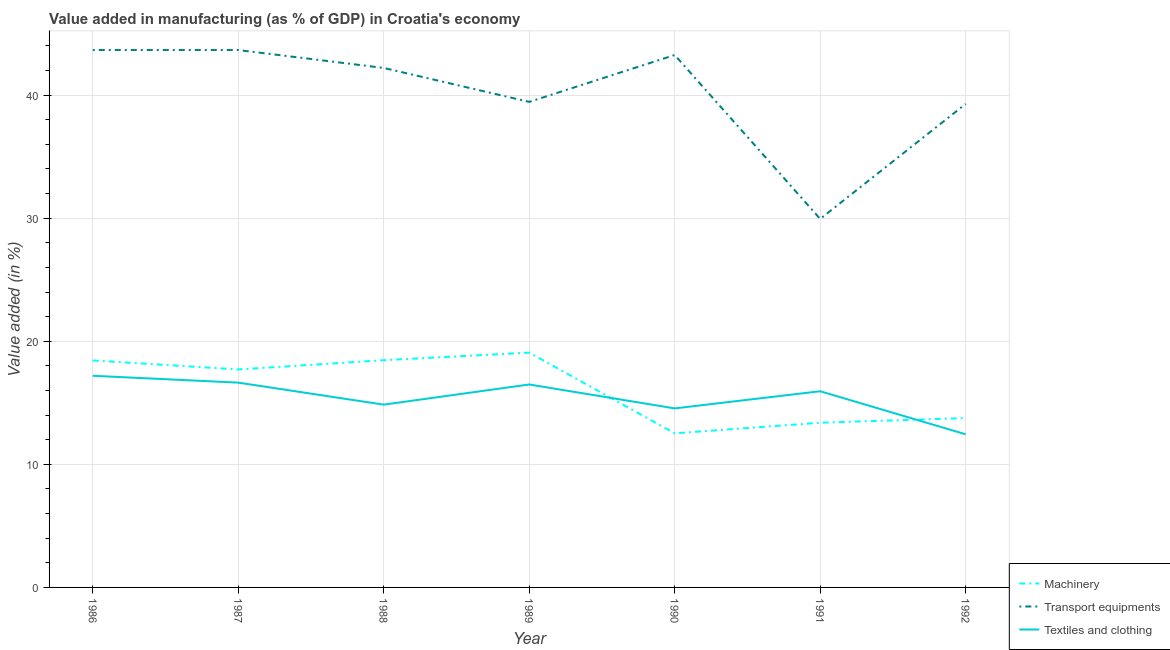Is the number of lines equal to the number of legend labels?
Provide a short and direct response. Yes. What is the value added in manufacturing machinery in 1988?
Offer a very short reply. 18.46. Across all years, what is the maximum value added in manufacturing textile and clothing?
Your response must be concise. 17.19. Across all years, what is the minimum value added in manufacturing machinery?
Provide a succinct answer. 12.52. In which year was the value added in manufacturing transport equipments maximum?
Provide a succinct answer. 1986. What is the total value added in manufacturing machinery in the graph?
Provide a short and direct response. 113.34. What is the difference between the value added in manufacturing textile and clothing in 1986 and that in 1991?
Provide a short and direct response. 1.26. What is the difference between the value added in manufacturing textile and clothing in 1992 and the value added in manufacturing transport equipments in 1988?
Your response must be concise. -29.76. What is the average value added in manufacturing textile and clothing per year?
Your response must be concise. 15.44. In the year 1989, what is the difference between the value added in manufacturing machinery and value added in manufacturing textile and clothing?
Keep it short and to the point. 2.59. What is the ratio of the value added in manufacturing transport equipments in 1989 to that in 1991?
Give a very brief answer. 1.32. Is the value added in manufacturing transport equipments in 1988 less than that in 1992?
Ensure brevity in your answer.  No. What is the difference between the highest and the second highest value added in manufacturing transport equipments?
Provide a succinct answer. 0. What is the difference between the highest and the lowest value added in manufacturing transport equipments?
Give a very brief answer. 13.72. Is it the case that in every year, the sum of the value added in manufacturing machinery and value added in manufacturing transport equipments is greater than the value added in manufacturing textile and clothing?
Offer a very short reply. Yes. Is the value added in manufacturing transport equipments strictly greater than the value added in manufacturing textile and clothing over the years?
Your response must be concise. Yes. How many years are there in the graph?
Give a very brief answer. 7. Are the values on the major ticks of Y-axis written in scientific E-notation?
Your response must be concise. No. Does the graph contain any zero values?
Offer a terse response. No. Does the graph contain grids?
Offer a terse response. Yes. Where does the legend appear in the graph?
Ensure brevity in your answer.  Bottom right. How many legend labels are there?
Ensure brevity in your answer.  3. How are the legend labels stacked?
Ensure brevity in your answer.  Vertical. What is the title of the graph?
Offer a terse response. Value added in manufacturing (as % of GDP) in Croatia's economy. What is the label or title of the X-axis?
Ensure brevity in your answer.  Year. What is the label or title of the Y-axis?
Make the answer very short. Value added (in %). What is the Value added (in %) of Machinery in 1986?
Keep it short and to the point. 18.44. What is the Value added (in %) of Transport equipments in 1986?
Give a very brief answer. 43.66. What is the Value added (in %) in Textiles and clothing in 1986?
Keep it short and to the point. 17.19. What is the Value added (in %) in Machinery in 1987?
Offer a terse response. 17.71. What is the Value added (in %) in Transport equipments in 1987?
Keep it short and to the point. 43.66. What is the Value added (in %) in Textiles and clothing in 1987?
Make the answer very short. 16.64. What is the Value added (in %) in Machinery in 1988?
Your answer should be very brief. 18.46. What is the Value added (in %) of Transport equipments in 1988?
Offer a very short reply. 42.2. What is the Value added (in %) of Textiles and clothing in 1988?
Offer a terse response. 14.85. What is the Value added (in %) in Machinery in 1989?
Provide a succinct answer. 19.08. What is the Value added (in %) in Transport equipments in 1989?
Give a very brief answer. 39.44. What is the Value added (in %) of Textiles and clothing in 1989?
Make the answer very short. 16.49. What is the Value added (in %) in Machinery in 1990?
Your answer should be compact. 12.52. What is the Value added (in %) of Transport equipments in 1990?
Offer a very short reply. 43.25. What is the Value added (in %) in Textiles and clothing in 1990?
Your answer should be compact. 14.54. What is the Value added (in %) of Machinery in 1991?
Provide a succinct answer. 13.38. What is the Value added (in %) of Transport equipments in 1991?
Keep it short and to the point. 29.94. What is the Value added (in %) of Textiles and clothing in 1991?
Provide a short and direct response. 15.94. What is the Value added (in %) in Machinery in 1992?
Your answer should be very brief. 13.76. What is the Value added (in %) in Transport equipments in 1992?
Keep it short and to the point. 39.28. What is the Value added (in %) of Textiles and clothing in 1992?
Offer a terse response. 12.44. Across all years, what is the maximum Value added (in %) of Machinery?
Ensure brevity in your answer.  19.08. Across all years, what is the maximum Value added (in %) in Transport equipments?
Provide a succinct answer. 43.66. Across all years, what is the maximum Value added (in %) of Textiles and clothing?
Provide a short and direct response. 17.19. Across all years, what is the minimum Value added (in %) in Machinery?
Keep it short and to the point. 12.52. Across all years, what is the minimum Value added (in %) of Transport equipments?
Your answer should be compact. 29.94. Across all years, what is the minimum Value added (in %) of Textiles and clothing?
Your answer should be compact. 12.44. What is the total Value added (in %) of Machinery in the graph?
Provide a succinct answer. 113.34. What is the total Value added (in %) in Transport equipments in the graph?
Make the answer very short. 281.43. What is the total Value added (in %) of Textiles and clothing in the graph?
Make the answer very short. 108.09. What is the difference between the Value added (in %) of Machinery in 1986 and that in 1987?
Your answer should be compact. 0.73. What is the difference between the Value added (in %) in Transport equipments in 1986 and that in 1987?
Your answer should be compact. 0. What is the difference between the Value added (in %) in Textiles and clothing in 1986 and that in 1987?
Your answer should be compact. 0.56. What is the difference between the Value added (in %) in Machinery in 1986 and that in 1988?
Your answer should be very brief. -0.02. What is the difference between the Value added (in %) of Transport equipments in 1986 and that in 1988?
Give a very brief answer. 1.45. What is the difference between the Value added (in %) of Textiles and clothing in 1986 and that in 1988?
Keep it short and to the point. 2.34. What is the difference between the Value added (in %) of Machinery in 1986 and that in 1989?
Give a very brief answer. -0.63. What is the difference between the Value added (in %) of Transport equipments in 1986 and that in 1989?
Offer a terse response. 4.21. What is the difference between the Value added (in %) of Textiles and clothing in 1986 and that in 1989?
Give a very brief answer. 0.71. What is the difference between the Value added (in %) of Machinery in 1986 and that in 1990?
Give a very brief answer. 5.92. What is the difference between the Value added (in %) of Transport equipments in 1986 and that in 1990?
Give a very brief answer. 0.4. What is the difference between the Value added (in %) in Textiles and clothing in 1986 and that in 1990?
Your answer should be very brief. 2.65. What is the difference between the Value added (in %) of Machinery in 1986 and that in 1991?
Offer a very short reply. 5.06. What is the difference between the Value added (in %) in Transport equipments in 1986 and that in 1991?
Your answer should be very brief. 13.72. What is the difference between the Value added (in %) of Textiles and clothing in 1986 and that in 1991?
Give a very brief answer. 1.26. What is the difference between the Value added (in %) in Machinery in 1986 and that in 1992?
Your response must be concise. 4.69. What is the difference between the Value added (in %) in Transport equipments in 1986 and that in 1992?
Keep it short and to the point. 4.38. What is the difference between the Value added (in %) of Textiles and clothing in 1986 and that in 1992?
Ensure brevity in your answer.  4.75. What is the difference between the Value added (in %) in Machinery in 1987 and that in 1988?
Keep it short and to the point. -0.75. What is the difference between the Value added (in %) in Transport equipments in 1987 and that in 1988?
Your answer should be very brief. 1.45. What is the difference between the Value added (in %) in Textiles and clothing in 1987 and that in 1988?
Make the answer very short. 1.79. What is the difference between the Value added (in %) in Machinery in 1987 and that in 1989?
Provide a succinct answer. -1.37. What is the difference between the Value added (in %) in Transport equipments in 1987 and that in 1989?
Your response must be concise. 4.21. What is the difference between the Value added (in %) in Textiles and clothing in 1987 and that in 1989?
Keep it short and to the point. 0.15. What is the difference between the Value added (in %) of Machinery in 1987 and that in 1990?
Your answer should be compact. 5.19. What is the difference between the Value added (in %) in Transport equipments in 1987 and that in 1990?
Provide a succinct answer. 0.4. What is the difference between the Value added (in %) in Textiles and clothing in 1987 and that in 1990?
Provide a short and direct response. 2.09. What is the difference between the Value added (in %) in Machinery in 1987 and that in 1991?
Keep it short and to the point. 4.33. What is the difference between the Value added (in %) in Transport equipments in 1987 and that in 1991?
Give a very brief answer. 13.72. What is the difference between the Value added (in %) of Textiles and clothing in 1987 and that in 1991?
Give a very brief answer. 0.7. What is the difference between the Value added (in %) of Machinery in 1987 and that in 1992?
Your answer should be very brief. 3.95. What is the difference between the Value added (in %) in Transport equipments in 1987 and that in 1992?
Provide a succinct answer. 4.38. What is the difference between the Value added (in %) in Textiles and clothing in 1987 and that in 1992?
Give a very brief answer. 4.2. What is the difference between the Value added (in %) of Machinery in 1988 and that in 1989?
Your answer should be compact. -0.61. What is the difference between the Value added (in %) in Transport equipments in 1988 and that in 1989?
Provide a succinct answer. 2.76. What is the difference between the Value added (in %) in Textiles and clothing in 1988 and that in 1989?
Your response must be concise. -1.64. What is the difference between the Value added (in %) of Machinery in 1988 and that in 1990?
Ensure brevity in your answer.  5.94. What is the difference between the Value added (in %) in Transport equipments in 1988 and that in 1990?
Offer a terse response. -1.05. What is the difference between the Value added (in %) in Textiles and clothing in 1988 and that in 1990?
Make the answer very short. 0.31. What is the difference between the Value added (in %) in Machinery in 1988 and that in 1991?
Ensure brevity in your answer.  5.08. What is the difference between the Value added (in %) in Transport equipments in 1988 and that in 1991?
Keep it short and to the point. 12.26. What is the difference between the Value added (in %) in Textiles and clothing in 1988 and that in 1991?
Keep it short and to the point. -1.09. What is the difference between the Value added (in %) in Machinery in 1988 and that in 1992?
Make the answer very short. 4.71. What is the difference between the Value added (in %) in Transport equipments in 1988 and that in 1992?
Your answer should be very brief. 2.92. What is the difference between the Value added (in %) in Textiles and clothing in 1988 and that in 1992?
Your response must be concise. 2.41. What is the difference between the Value added (in %) in Machinery in 1989 and that in 1990?
Make the answer very short. 6.56. What is the difference between the Value added (in %) of Transport equipments in 1989 and that in 1990?
Your response must be concise. -3.81. What is the difference between the Value added (in %) in Textiles and clothing in 1989 and that in 1990?
Make the answer very short. 1.94. What is the difference between the Value added (in %) in Machinery in 1989 and that in 1991?
Offer a very short reply. 5.69. What is the difference between the Value added (in %) in Transport equipments in 1989 and that in 1991?
Give a very brief answer. 9.51. What is the difference between the Value added (in %) of Textiles and clothing in 1989 and that in 1991?
Provide a succinct answer. 0.55. What is the difference between the Value added (in %) in Machinery in 1989 and that in 1992?
Your answer should be compact. 5.32. What is the difference between the Value added (in %) of Transport equipments in 1989 and that in 1992?
Offer a very short reply. 0.17. What is the difference between the Value added (in %) of Textiles and clothing in 1989 and that in 1992?
Ensure brevity in your answer.  4.05. What is the difference between the Value added (in %) in Machinery in 1990 and that in 1991?
Give a very brief answer. -0.86. What is the difference between the Value added (in %) of Transport equipments in 1990 and that in 1991?
Give a very brief answer. 13.31. What is the difference between the Value added (in %) of Textiles and clothing in 1990 and that in 1991?
Provide a short and direct response. -1.39. What is the difference between the Value added (in %) in Machinery in 1990 and that in 1992?
Your answer should be very brief. -1.24. What is the difference between the Value added (in %) in Transport equipments in 1990 and that in 1992?
Your answer should be compact. 3.98. What is the difference between the Value added (in %) in Textiles and clothing in 1990 and that in 1992?
Provide a succinct answer. 2.1. What is the difference between the Value added (in %) in Machinery in 1991 and that in 1992?
Make the answer very short. -0.37. What is the difference between the Value added (in %) of Transport equipments in 1991 and that in 1992?
Provide a short and direct response. -9.34. What is the difference between the Value added (in %) in Textiles and clothing in 1991 and that in 1992?
Give a very brief answer. 3.5. What is the difference between the Value added (in %) of Machinery in 1986 and the Value added (in %) of Transport equipments in 1987?
Provide a short and direct response. -25.21. What is the difference between the Value added (in %) in Machinery in 1986 and the Value added (in %) in Textiles and clothing in 1987?
Provide a short and direct response. 1.8. What is the difference between the Value added (in %) of Transport equipments in 1986 and the Value added (in %) of Textiles and clothing in 1987?
Make the answer very short. 27.02. What is the difference between the Value added (in %) in Machinery in 1986 and the Value added (in %) in Transport equipments in 1988?
Your answer should be very brief. -23.76. What is the difference between the Value added (in %) of Machinery in 1986 and the Value added (in %) of Textiles and clothing in 1988?
Offer a very short reply. 3.59. What is the difference between the Value added (in %) of Transport equipments in 1986 and the Value added (in %) of Textiles and clothing in 1988?
Give a very brief answer. 28.81. What is the difference between the Value added (in %) in Machinery in 1986 and the Value added (in %) in Transport equipments in 1989?
Offer a terse response. -21. What is the difference between the Value added (in %) of Machinery in 1986 and the Value added (in %) of Textiles and clothing in 1989?
Make the answer very short. 1.95. What is the difference between the Value added (in %) in Transport equipments in 1986 and the Value added (in %) in Textiles and clothing in 1989?
Provide a succinct answer. 27.17. What is the difference between the Value added (in %) of Machinery in 1986 and the Value added (in %) of Transport equipments in 1990?
Your answer should be compact. -24.81. What is the difference between the Value added (in %) of Machinery in 1986 and the Value added (in %) of Textiles and clothing in 1990?
Offer a very short reply. 3.9. What is the difference between the Value added (in %) of Transport equipments in 1986 and the Value added (in %) of Textiles and clothing in 1990?
Provide a succinct answer. 29.11. What is the difference between the Value added (in %) in Machinery in 1986 and the Value added (in %) in Transport equipments in 1991?
Keep it short and to the point. -11.5. What is the difference between the Value added (in %) of Machinery in 1986 and the Value added (in %) of Textiles and clothing in 1991?
Ensure brevity in your answer.  2.5. What is the difference between the Value added (in %) of Transport equipments in 1986 and the Value added (in %) of Textiles and clothing in 1991?
Offer a very short reply. 27.72. What is the difference between the Value added (in %) in Machinery in 1986 and the Value added (in %) in Transport equipments in 1992?
Make the answer very short. -20.84. What is the difference between the Value added (in %) of Machinery in 1986 and the Value added (in %) of Textiles and clothing in 1992?
Give a very brief answer. 6. What is the difference between the Value added (in %) of Transport equipments in 1986 and the Value added (in %) of Textiles and clothing in 1992?
Make the answer very short. 31.22. What is the difference between the Value added (in %) of Machinery in 1987 and the Value added (in %) of Transport equipments in 1988?
Your answer should be compact. -24.49. What is the difference between the Value added (in %) in Machinery in 1987 and the Value added (in %) in Textiles and clothing in 1988?
Offer a very short reply. 2.86. What is the difference between the Value added (in %) in Transport equipments in 1987 and the Value added (in %) in Textiles and clothing in 1988?
Make the answer very short. 28.81. What is the difference between the Value added (in %) in Machinery in 1987 and the Value added (in %) in Transport equipments in 1989?
Give a very brief answer. -21.74. What is the difference between the Value added (in %) in Machinery in 1987 and the Value added (in %) in Textiles and clothing in 1989?
Your response must be concise. 1.22. What is the difference between the Value added (in %) in Transport equipments in 1987 and the Value added (in %) in Textiles and clothing in 1989?
Keep it short and to the point. 27.17. What is the difference between the Value added (in %) of Machinery in 1987 and the Value added (in %) of Transport equipments in 1990?
Give a very brief answer. -25.54. What is the difference between the Value added (in %) in Machinery in 1987 and the Value added (in %) in Textiles and clothing in 1990?
Keep it short and to the point. 3.16. What is the difference between the Value added (in %) in Transport equipments in 1987 and the Value added (in %) in Textiles and clothing in 1990?
Offer a very short reply. 29.11. What is the difference between the Value added (in %) in Machinery in 1987 and the Value added (in %) in Transport equipments in 1991?
Your answer should be very brief. -12.23. What is the difference between the Value added (in %) of Machinery in 1987 and the Value added (in %) of Textiles and clothing in 1991?
Provide a succinct answer. 1.77. What is the difference between the Value added (in %) in Transport equipments in 1987 and the Value added (in %) in Textiles and clothing in 1991?
Offer a very short reply. 27.72. What is the difference between the Value added (in %) in Machinery in 1987 and the Value added (in %) in Transport equipments in 1992?
Your answer should be compact. -21.57. What is the difference between the Value added (in %) in Machinery in 1987 and the Value added (in %) in Textiles and clothing in 1992?
Keep it short and to the point. 5.27. What is the difference between the Value added (in %) of Transport equipments in 1987 and the Value added (in %) of Textiles and clothing in 1992?
Give a very brief answer. 31.22. What is the difference between the Value added (in %) of Machinery in 1988 and the Value added (in %) of Transport equipments in 1989?
Make the answer very short. -20.98. What is the difference between the Value added (in %) in Machinery in 1988 and the Value added (in %) in Textiles and clothing in 1989?
Give a very brief answer. 1.97. What is the difference between the Value added (in %) in Transport equipments in 1988 and the Value added (in %) in Textiles and clothing in 1989?
Offer a very short reply. 25.72. What is the difference between the Value added (in %) in Machinery in 1988 and the Value added (in %) in Transport equipments in 1990?
Offer a terse response. -24.79. What is the difference between the Value added (in %) of Machinery in 1988 and the Value added (in %) of Textiles and clothing in 1990?
Offer a very short reply. 3.92. What is the difference between the Value added (in %) in Transport equipments in 1988 and the Value added (in %) in Textiles and clothing in 1990?
Your response must be concise. 27.66. What is the difference between the Value added (in %) in Machinery in 1988 and the Value added (in %) in Transport equipments in 1991?
Your answer should be very brief. -11.48. What is the difference between the Value added (in %) of Machinery in 1988 and the Value added (in %) of Textiles and clothing in 1991?
Keep it short and to the point. 2.52. What is the difference between the Value added (in %) in Transport equipments in 1988 and the Value added (in %) in Textiles and clothing in 1991?
Give a very brief answer. 26.26. What is the difference between the Value added (in %) in Machinery in 1988 and the Value added (in %) in Transport equipments in 1992?
Your answer should be compact. -20.82. What is the difference between the Value added (in %) of Machinery in 1988 and the Value added (in %) of Textiles and clothing in 1992?
Offer a terse response. 6.02. What is the difference between the Value added (in %) of Transport equipments in 1988 and the Value added (in %) of Textiles and clothing in 1992?
Make the answer very short. 29.76. What is the difference between the Value added (in %) of Machinery in 1989 and the Value added (in %) of Transport equipments in 1990?
Provide a succinct answer. -24.18. What is the difference between the Value added (in %) in Machinery in 1989 and the Value added (in %) in Textiles and clothing in 1990?
Provide a succinct answer. 4.53. What is the difference between the Value added (in %) of Transport equipments in 1989 and the Value added (in %) of Textiles and clothing in 1990?
Make the answer very short. 24.9. What is the difference between the Value added (in %) of Machinery in 1989 and the Value added (in %) of Transport equipments in 1991?
Provide a short and direct response. -10.86. What is the difference between the Value added (in %) in Machinery in 1989 and the Value added (in %) in Textiles and clothing in 1991?
Keep it short and to the point. 3.14. What is the difference between the Value added (in %) in Transport equipments in 1989 and the Value added (in %) in Textiles and clothing in 1991?
Offer a terse response. 23.51. What is the difference between the Value added (in %) in Machinery in 1989 and the Value added (in %) in Transport equipments in 1992?
Ensure brevity in your answer.  -20.2. What is the difference between the Value added (in %) in Machinery in 1989 and the Value added (in %) in Textiles and clothing in 1992?
Your answer should be very brief. 6.64. What is the difference between the Value added (in %) in Transport equipments in 1989 and the Value added (in %) in Textiles and clothing in 1992?
Offer a terse response. 27. What is the difference between the Value added (in %) in Machinery in 1990 and the Value added (in %) in Transport equipments in 1991?
Give a very brief answer. -17.42. What is the difference between the Value added (in %) in Machinery in 1990 and the Value added (in %) in Textiles and clothing in 1991?
Keep it short and to the point. -3.42. What is the difference between the Value added (in %) in Transport equipments in 1990 and the Value added (in %) in Textiles and clothing in 1991?
Keep it short and to the point. 27.31. What is the difference between the Value added (in %) in Machinery in 1990 and the Value added (in %) in Transport equipments in 1992?
Provide a short and direct response. -26.76. What is the difference between the Value added (in %) of Machinery in 1990 and the Value added (in %) of Textiles and clothing in 1992?
Your answer should be very brief. 0.08. What is the difference between the Value added (in %) of Transport equipments in 1990 and the Value added (in %) of Textiles and clothing in 1992?
Offer a terse response. 30.81. What is the difference between the Value added (in %) of Machinery in 1991 and the Value added (in %) of Transport equipments in 1992?
Make the answer very short. -25.9. What is the difference between the Value added (in %) of Machinery in 1991 and the Value added (in %) of Textiles and clothing in 1992?
Your response must be concise. 0.94. What is the difference between the Value added (in %) in Transport equipments in 1991 and the Value added (in %) in Textiles and clothing in 1992?
Keep it short and to the point. 17.5. What is the average Value added (in %) of Machinery per year?
Offer a terse response. 16.19. What is the average Value added (in %) of Transport equipments per year?
Provide a succinct answer. 40.2. What is the average Value added (in %) in Textiles and clothing per year?
Provide a short and direct response. 15.44. In the year 1986, what is the difference between the Value added (in %) in Machinery and Value added (in %) in Transport equipments?
Ensure brevity in your answer.  -25.22. In the year 1986, what is the difference between the Value added (in %) in Machinery and Value added (in %) in Textiles and clothing?
Your answer should be very brief. 1.25. In the year 1986, what is the difference between the Value added (in %) in Transport equipments and Value added (in %) in Textiles and clothing?
Offer a terse response. 26.46. In the year 1987, what is the difference between the Value added (in %) of Machinery and Value added (in %) of Transport equipments?
Offer a terse response. -25.95. In the year 1987, what is the difference between the Value added (in %) of Machinery and Value added (in %) of Textiles and clothing?
Give a very brief answer. 1.07. In the year 1987, what is the difference between the Value added (in %) of Transport equipments and Value added (in %) of Textiles and clothing?
Your answer should be very brief. 27.02. In the year 1988, what is the difference between the Value added (in %) in Machinery and Value added (in %) in Transport equipments?
Your answer should be very brief. -23.74. In the year 1988, what is the difference between the Value added (in %) in Machinery and Value added (in %) in Textiles and clothing?
Ensure brevity in your answer.  3.61. In the year 1988, what is the difference between the Value added (in %) of Transport equipments and Value added (in %) of Textiles and clothing?
Ensure brevity in your answer.  27.35. In the year 1989, what is the difference between the Value added (in %) in Machinery and Value added (in %) in Transport equipments?
Offer a terse response. -20.37. In the year 1989, what is the difference between the Value added (in %) in Machinery and Value added (in %) in Textiles and clothing?
Make the answer very short. 2.59. In the year 1989, what is the difference between the Value added (in %) of Transport equipments and Value added (in %) of Textiles and clothing?
Make the answer very short. 22.96. In the year 1990, what is the difference between the Value added (in %) of Machinery and Value added (in %) of Transport equipments?
Provide a short and direct response. -30.73. In the year 1990, what is the difference between the Value added (in %) of Machinery and Value added (in %) of Textiles and clothing?
Provide a succinct answer. -2.03. In the year 1990, what is the difference between the Value added (in %) in Transport equipments and Value added (in %) in Textiles and clothing?
Provide a short and direct response. 28.71. In the year 1991, what is the difference between the Value added (in %) in Machinery and Value added (in %) in Transport equipments?
Provide a short and direct response. -16.56. In the year 1991, what is the difference between the Value added (in %) of Machinery and Value added (in %) of Textiles and clothing?
Ensure brevity in your answer.  -2.56. In the year 1991, what is the difference between the Value added (in %) in Transport equipments and Value added (in %) in Textiles and clothing?
Keep it short and to the point. 14. In the year 1992, what is the difference between the Value added (in %) of Machinery and Value added (in %) of Transport equipments?
Keep it short and to the point. -25.52. In the year 1992, what is the difference between the Value added (in %) of Machinery and Value added (in %) of Textiles and clothing?
Ensure brevity in your answer.  1.32. In the year 1992, what is the difference between the Value added (in %) of Transport equipments and Value added (in %) of Textiles and clothing?
Offer a very short reply. 26.84. What is the ratio of the Value added (in %) in Machinery in 1986 to that in 1987?
Ensure brevity in your answer.  1.04. What is the ratio of the Value added (in %) in Transport equipments in 1986 to that in 1987?
Make the answer very short. 1. What is the ratio of the Value added (in %) of Textiles and clothing in 1986 to that in 1987?
Your response must be concise. 1.03. What is the ratio of the Value added (in %) in Transport equipments in 1986 to that in 1988?
Keep it short and to the point. 1.03. What is the ratio of the Value added (in %) of Textiles and clothing in 1986 to that in 1988?
Your answer should be very brief. 1.16. What is the ratio of the Value added (in %) of Machinery in 1986 to that in 1989?
Keep it short and to the point. 0.97. What is the ratio of the Value added (in %) of Transport equipments in 1986 to that in 1989?
Your response must be concise. 1.11. What is the ratio of the Value added (in %) of Textiles and clothing in 1986 to that in 1989?
Your answer should be very brief. 1.04. What is the ratio of the Value added (in %) in Machinery in 1986 to that in 1990?
Offer a very short reply. 1.47. What is the ratio of the Value added (in %) in Transport equipments in 1986 to that in 1990?
Make the answer very short. 1.01. What is the ratio of the Value added (in %) of Textiles and clothing in 1986 to that in 1990?
Your answer should be compact. 1.18. What is the ratio of the Value added (in %) in Machinery in 1986 to that in 1991?
Offer a terse response. 1.38. What is the ratio of the Value added (in %) of Transport equipments in 1986 to that in 1991?
Provide a short and direct response. 1.46. What is the ratio of the Value added (in %) of Textiles and clothing in 1986 to that in 1991?
Your answer should be compact. 1.08. What is the ratio of the Value added (in %) in Machinery in 1986 to that in 1992?
Offer a very short reply. 1.34. What is the ratio of the Value added (in %) in Transport equipments in 1986 to that in 1992?
Your answer should be very brief. 1.11. What is the ratio of the Value added (in %) in Textiles and clothing in 1986 to that in 1992?
Your answer should be compact. 1.38. What is the ratio of the Value added (in %) in Machinery in 1987 to that in 1988?
Give a very brief answer. 0.96. What is the ratio of the Value added (in %) in Transport equipments in 1987 to that in 1988?
Your answer should be compact. 1.03. What is the ratio of the Value added (in %) of Textiles and clothing in 1987 to that in 1988?
Your answer should be compact. 1.12. What is the ratio of the Value added (in %) in Machinery in 1987 to that in 1989?
Your answer should be compact. 0.93. What is the ratio of the Value added (in %) of Transport equipments in 1987 to that in 1989?
Your answer should be compact. 1.11. What is the ratio of the Value added (in %) in Textiles and clothing in 1987 to that in 1989?
Ensure brevity in your answer.  1.01. What is the ratio of the Value added (in %) in Machinery in 1987 to that in 1990?
Provide a short and direct response. 1.41. What is the ratio of the Value added (in %) of Transport equipments in 1987 to that in 1990?
Your response must be concise. 1.01. What is the ratio of the Value added (in %) in Textiles and clothing in 1987 to that in 1990?
Your answer should be compact. 1.14. What is the ratio of the Value added (in %) in Machinery in 1987 to that in 1991?
Offer a terse response. 1.32. What is the ratio of the Value added (in %) in Transport equipments in 1987 to that in 1991?
Provide a succinct answer. 1.46. What is the ratio of the Value added (in %) of Textiles and clothing in 1987 to that in 1991?
Keep it short and to the point. 1.04. What is the ratio of the Value added (in %) in Machinery in 1987 to that in 1992?
Give a very brief answer. 1.29. What is the ratio of the Value added (in %) in Transport equipments in 1987 to that in 1992?
Provide a short and direct response. 1.11. What is the ratio of the Value added (in %) of Textiles and clothing in 1987 to that in 1992?
Your response must be concise. 1.34. What is the ratio of the Value added (in %) in Machinery in 1988 to that in 1989?
Provide a succinct answer. 0.97. What is the ratio of the Value added (in %) of Transport equipments in 1988 to that in 1989?
Keep it short and to the point. 1.07. What is the ratio of the Value added (in %) in Textiles and clothing in 1988 to that in 1989?
Your answer should be compact. 0.9. What is the ratio of the Value added (in %) of Machinery in 1988 to that in 1990?
Offer a terse response. 1.47. What is the ratio of the Value added (in %) in Transport equipments in 1988 to that in 1990?
Provide a succinct answer. 0.98. What is the ratio of the Value added (in %) in Machinery in 1988 to that in 1991?
Your response must be concise. 1.38. What is the ratio of the Value added (in %) of Transport equipments in 1988 to that in 1991?
Your response must be concise. 1.41. What is the ratio of the Value added (in %) of Textiles and clothing in 1988 to that in 1991?
Ensure brevity in your answer.  0.93. What is the ratio of the Value added (in %) in Machinery in 1988 to that in 1992?
Give a very brief answer. 1.34. What is the ratio of the Value added (in %) in Transport equipments in 1988 to that in 1992?
Make the answer very short. 1.07. What is the ratio of the Value added (in %) in Textiles and clothing in 1988 to that in 1992?
Give a very brief answer. 1.19. What is the ratio of the Value added (in %) of Machinery in 1989 to that in 1990?
Give a very brief answer. 1.52. What is the ratio of the Value added (in %) in Transport equipments in 1989 to that in 1990?
Ensure brevity in your answer.  0.91. What is the ratio of the Value added (in %) in Textiles and clothing in 1989 to that in 1990?
Your answer should be very brief. 1.13. What is the ratio of the Value added (in %) in Machinery in 1989 to that in 1991?
Your answer should be compact. 1.43. What is the ratio of the Value added (in %) in Transport equipments in 1989 to that in 1991?
Provide a short and direct response. 1.32. What is the ratio of the Value added (in %) in Textiles and clothing in 1989 to that in 1991?
Ensure brevity in your answer.  1.03. What is the ratio of the Value added (in %) of Machinery in 1989 to that in 1992?
Your answer should be very brief. 1.39. What is the ratio of the Value added (in %) of Transport equipments in 1989 to that in 1992?
Give a very brief answer. 1. What is the ratio of the Value added (in %) of Textiles and clothing in 1989 to that in 1992?
Your answer should be compact. 1.33. What is the ratio of the Value added (in %) of Machinery in 1990 to that in 1991?
Offer a very short reply. 0.94. What is the ratio of the Value added (in %) in Transport equipments in 1990 to that in 1991?
Provide a succinct answer. 1.44. What is the ratio of the Value added (in %) of Textiles and clothing in 1990 to that in 1991?
Keep it short and to the point. 0.91. What is the ratio of the Value added (in %) of Machinery in 1990 to that in 1992?
Make the answer very short. 0.91. What is the ratio of the Value added (in %) of Transport equipments in 1990 to that in 1992?
Offer a very short reply. 1.1. What is the ratio of the Value added (in %) in Textiles and clothing in 1990 to that in 1992?
Offer a very short reply. 1.17. What is the ratio of the Value added (in %) in Machinery in 1991 to that in 1992?
Keep it short and to the point. 0.97. What is the ratio of the Value added (in %) in Transport equipments in 1991 to that in 1992?
Offer a very short reply. 0.76. What is the ratio of the Value added (in %) in Textiles and clothing in 1991 to that in 1992?
Ensure brevity in your answer.  1.28. What is the difference between the highest and the second highest Value added (in %) in Machinery?
Keep it short and to the point. 0.61. What is the difference between the highest and the second highest Value added (in %) of Transport equipments?
Keep it short and to the point. 0. What is the difference between the highest and the second highest Value added (in %) in Textiles and clothing?
Your response must be concise. 0.56. What is the difference between the highest and the lowest Value added (in %) in Machinery?
Give a very brief answer. 6.56. What is the difference between the highest and the lowest Value added (in %) in Transport equipments?
Your response must be concise. 13.72. What is the difference between the highest and the lowest Value added (in %) of Textiles and clothing?
Your answer should be very brief. 4.75. 